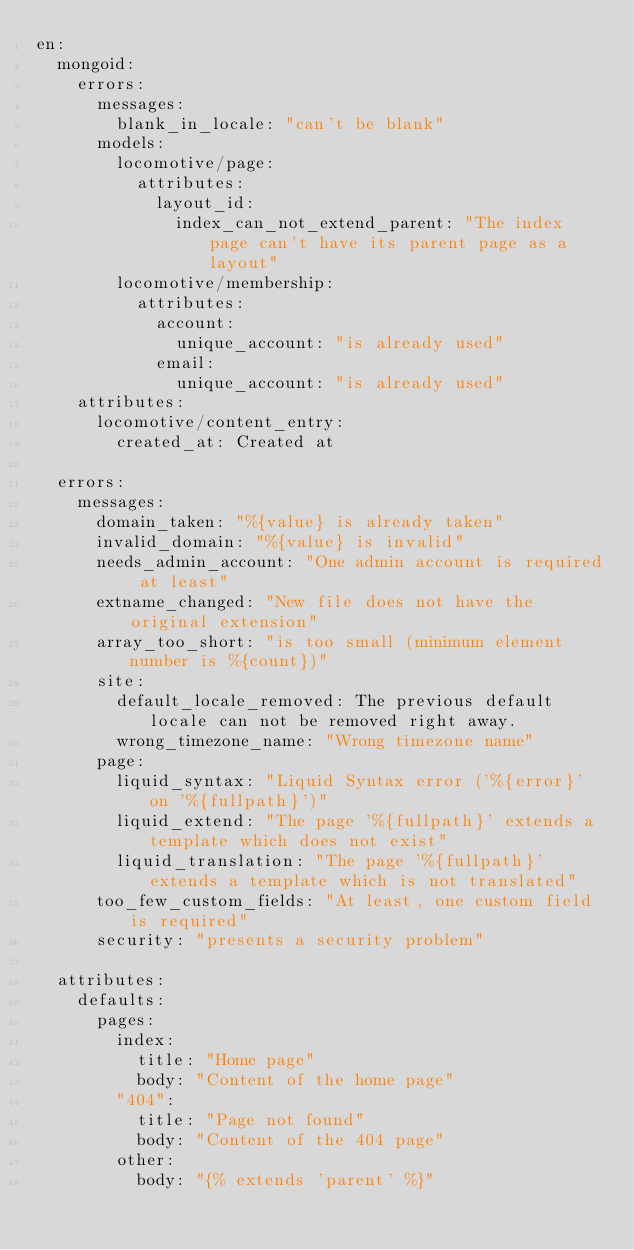Convert code to text. <code><loc_0><loc_0><loc_500><loc_500><_YAML_>en:
  mongoid:
    errors:
      messages:
        blank_in_locale: "can't be blank"
      models:
        locomotive/page:
          attributes:
            layout_id:
              index_can_not_extend_parent: "The index page can't have its parent page as a layout"
        locomotive/membership:
          attributes:
            account:
              unique_account: "is already used"
            email:
              unique_account: "is already used"
    attributes:
      locomotive/content_entry:
        created_at: Created at

  errors:
    messages:
      domain_taken: "%{value} is already taken"
      invalid_domain: "%{value} is invalid"
      needs_admin_account: "One admin account is required at least"
      extname_changed: "New file does not have the original extension"
      array_too_short: "is too small (minimum element number is %{count})"
      site:
        default_locale_removed: The previous default locale can not be removed right away.
        wrong_timezone_name: "Wrong timezone name"
      page:
        liquid_syntax: "Liquid Syntax error ('%{error}' on '%{fullpath}')"
        liquid_extend: "The page '%{fullpath}' extends a template which does not exist"
        liquid_translation: "The page '%{fullpath}' extends a template which is not translated"
      too_few_custom_fields: "At least, one custom field is required"
      security: "presents a security problem"

  attributes:
    defaults:
      pages:
        index:
          title: "Home page"
          body: "Content of the home page"
        "404":
          title: "Page not found"
          body: "Content of the 404 page"
        other:
          body: "{% extends 'parent' %}"
</code> 